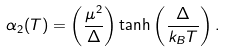<formula> <loc_0><loc_0><loc_500><loc_500>\alpha _ { 2 } ( T ) = \left ( \frac { \mu ^ { 2 } } { \Delta } \right ) \tanh \left ( \frac { \Delta } { k _ { B } T } \right ) .</formula> 